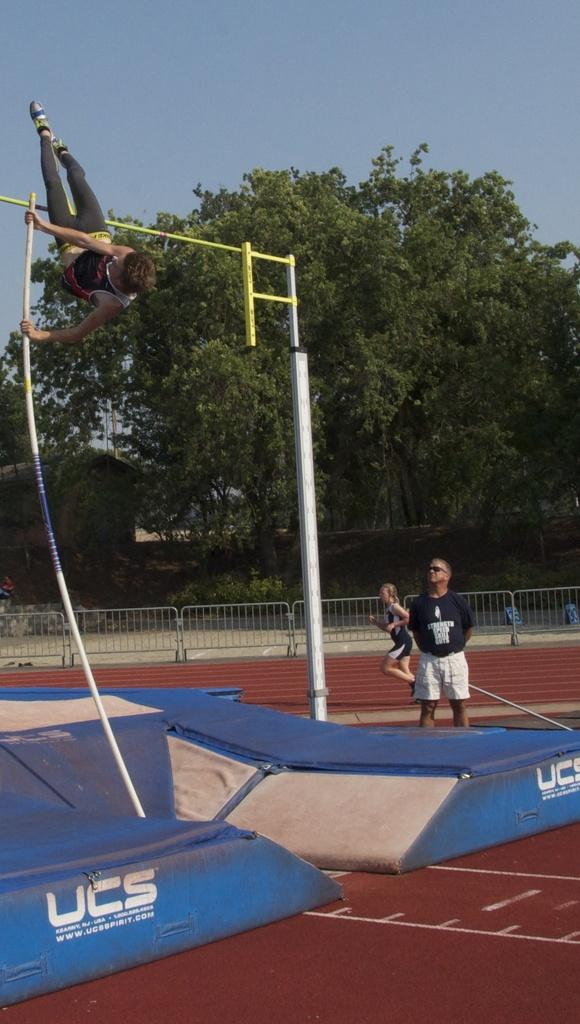What activity is the person on the left side of the image performing? The person on the left side of the image is doing a pole jump. What is located at the bottom of the image? There is a trampoline at the bottom of the image. What can be seen in the background of the image? There are people, a fence, trees, and the sky visible in the background of the image. What type of blood is visible on the trail in the image? There is no blood or trail present in the image. 